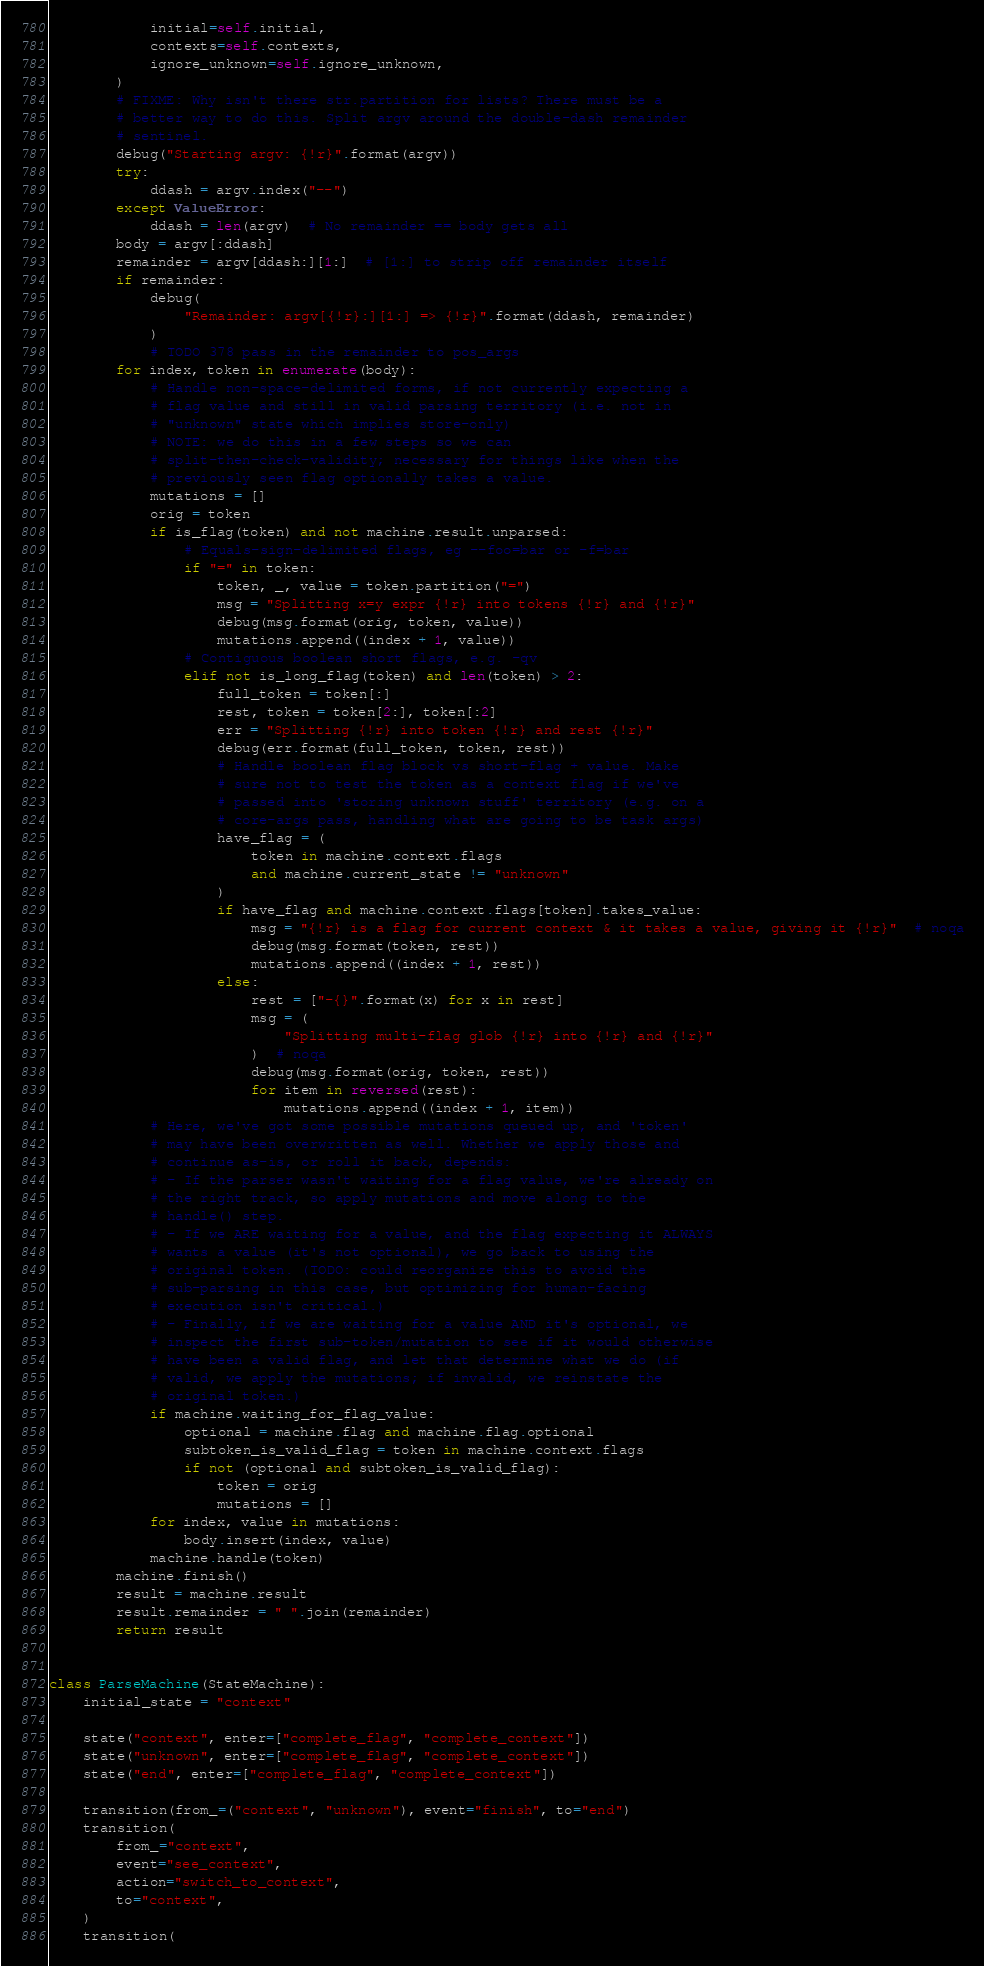Convert code to text. <code><loc_0><loc_0><loc_500><loc_500><_Python_>            initial=self.initial,
            contexts=self.contexts,
            ignore_unknown=self.ignore_unknown,
        )
        # FIXME: Why isn't there str.partition for lists? There must be a
        # better way to do this. Split argv around the double-dash remainder
        # sentinel.
        debug("Starting argv: {!r}".format(argv))
        try:
            ddash = argv.index("--")
        except ValueError:
            ddash = len(argv)  # No remainder == body gets all
        body = argv[:ddash]
        remainder = argv[ddash:][1:]  # [1:] to strip off remainder itself
        if remainder:
            debug(
                "Remainder: argv[{!r}:][1:] => {!r}".format(ddash, remainder)
            )
            # TODO 378 pass in the remainder to pos_args
        for index, token in enumerate(body):
            # Handle non-space-delimited forms, if not currently expecting a
            # flag value and still in valid parsing territory (i.e. not in
            # "unknown" state which implies store-only)
            # NOTE: we do this in a few steps so we can
            # split-then-check-validity; necessary for things like when the
            # previously seen flag optionally takes a value.
            mutations = []
            orig = token
            if is_flag(token) and not machine.result.unparsed:
                # Equals-sign-delimited flags, eg --foo=bar or -f=bar
                if "=" in token:
                    token, _, value = token.partition("=")
                    msg = "Splitting x=y expr {!r} into tokens {!r} and {!r}"
                    debug(msg.format(orig, token, value))
                    mutations.append((index + 1, value))
                # Contiguous boolean short flags, e.g. -qv
                elif not is_long_flag(token) and len(token) > 2:
                    full_token = token[:]
                    rest, token = token[2:], token[:2]
                    err = "Splitting {!r} into token {!r} and rest {!r}"
                    debug(err.format(full_token, token, rest))
                    # Handle boolean flag block vs short-flag + value. Make
                    # sure not to test the token as a context flag if we've
                    # passed into 'storing unknown stuff' territory (e.g. on a
                    # core-args pass, handling what are going to be task args)
                    have_flag = (
                        token in machine.context.flags
                        and machine.current_state != "unknown"
                    )
                    if have_flag and machine.context.flags[token].takes_value:
                        msg = "{!r} is a flag for current context & it takes a value, giving it {!r}"  # noqa
                        debug(msg.format(token, rest))
                        mutations.append((index + 1, rest))
                    else:
                        rest = ["-{}".format(x) for x in rest]
                        msg = (
                            "Splitting multi-flag glob {!r} into {!r} and {!r}"
                        )  # noqa
                        debug(msg.format(orig, token, rest))
                        for item in reversed(rest):
                            mutations.append((index + 1, item))
            # Here, we've got some possible mutations queued up, and 'token'
            # may have been overwritten as well. Whether we apply those and
            # continue as-is, or roll it back, depends:
            # - If the parser wasn't waiting for a flag value, we're already on
            # the right track, so apply mutations and move along to the
            # handle() step.
            # - If we ARE waiting for a value, and the flag expecting it ALWAYS
            # wants a value (it's not optional), we go back to using the
            # original token. (TODO: could reorganize this to avoid the
            # sub-parsing in this case, but optimizing for human-facing
            # execution isn't critical.)
            # - Finally, if we are waiting for a value AND it's optional, we
            # inspect the first sub-token/mutation to see if it would otherwise
            # have been a valid flag, and let that determine what we do (if
            # valid, we apply the mutations; if invalid, we reinstate the
            # original token.)
            if machine.waiting_for_flag_value:
                optional = machine.flag and machine.flag.optional
                subtoken_is_valid_flag = token in machine.context.flags
                if not (optional and subtoken_is_valid_flag):
                    token = orig
                    mutations = []
            for index, value in mutations:
                body.insert(index, value)
            machine.handle(token)
        machine.finish()
        result = machine.result
        result.remainder = " ".join(remainder)
        return result


class ParseMachine(StateMachine):
    initial_state = "context"

    state("context", enter=["complete_flag", "complete_context"])
    state("unknown", enter=["complete_flag", "complete_context"])
    state("end", enter=["complete_flag", "complete_context"])

    transition(from_=("context", "unknown"), event="finish", to="end")
    transition(
        from_="context",
        event="see_context",
        action="switch_to_context",
        to="context",
    )
    transition(</code> 